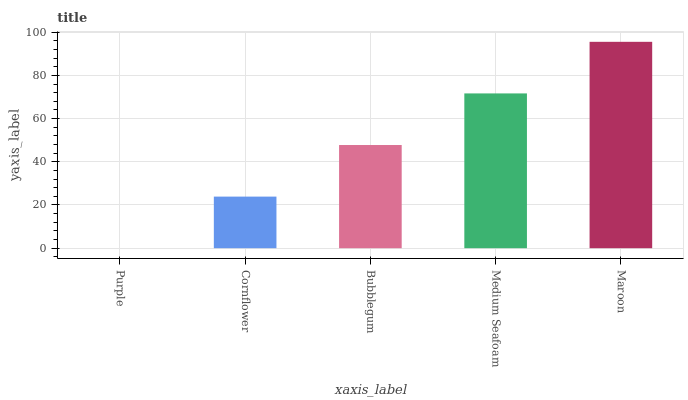Is Purple the minimum?
Answer yes or no. Yes. Is Maroon the maximum?
Answer yes or no. Yes. Is Cornflower the minimum?
Answer yes or no. No. Is Cornflower the maximum?
Answer yes or no. No. Is Cornflower greater than Purple?
Answer yes or no. Yes. Is Purple less than Cornflower?
Answer yes or no. Yes. Is Purple greater than Cornflower?
Answer yes or no. No. Is Cornflower less than Purple?
Answer yes or no. No. Is Bubblegum the high median?
Answer yes or no. Yes. Is Bubblegum the low median?
Answer yes or no. Yes. Is Medium Seafoam the high median?
Answer yes or no. No. Is Medium Seafoam the low median?
Answer yes or no. No. 